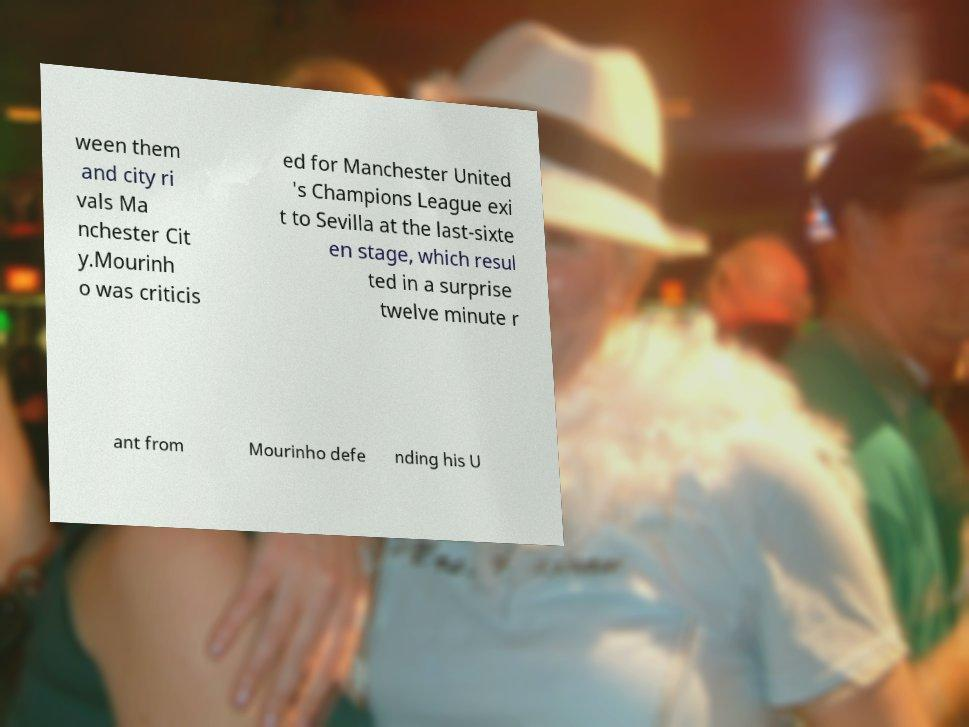Please identify and transcribe the text found in this image. ween them and city ri vals Ma nchester Cit y.Mourinh o was criticis ed for Manchester United 's Champions League exi t to Sevilla at the last-sixte en stage, which resul ted in a surprise twelve minute r ant from Mourinho defe nding his U 